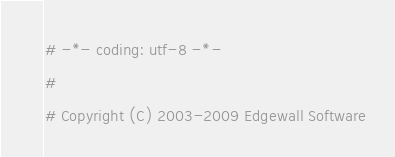<code> <loc_0><loc_0><loc_500><loc_500><_Python_># -*- coding: utf-8 -*-
#
# Copyright (C) 2003-2009 Edgewall Software</code> 